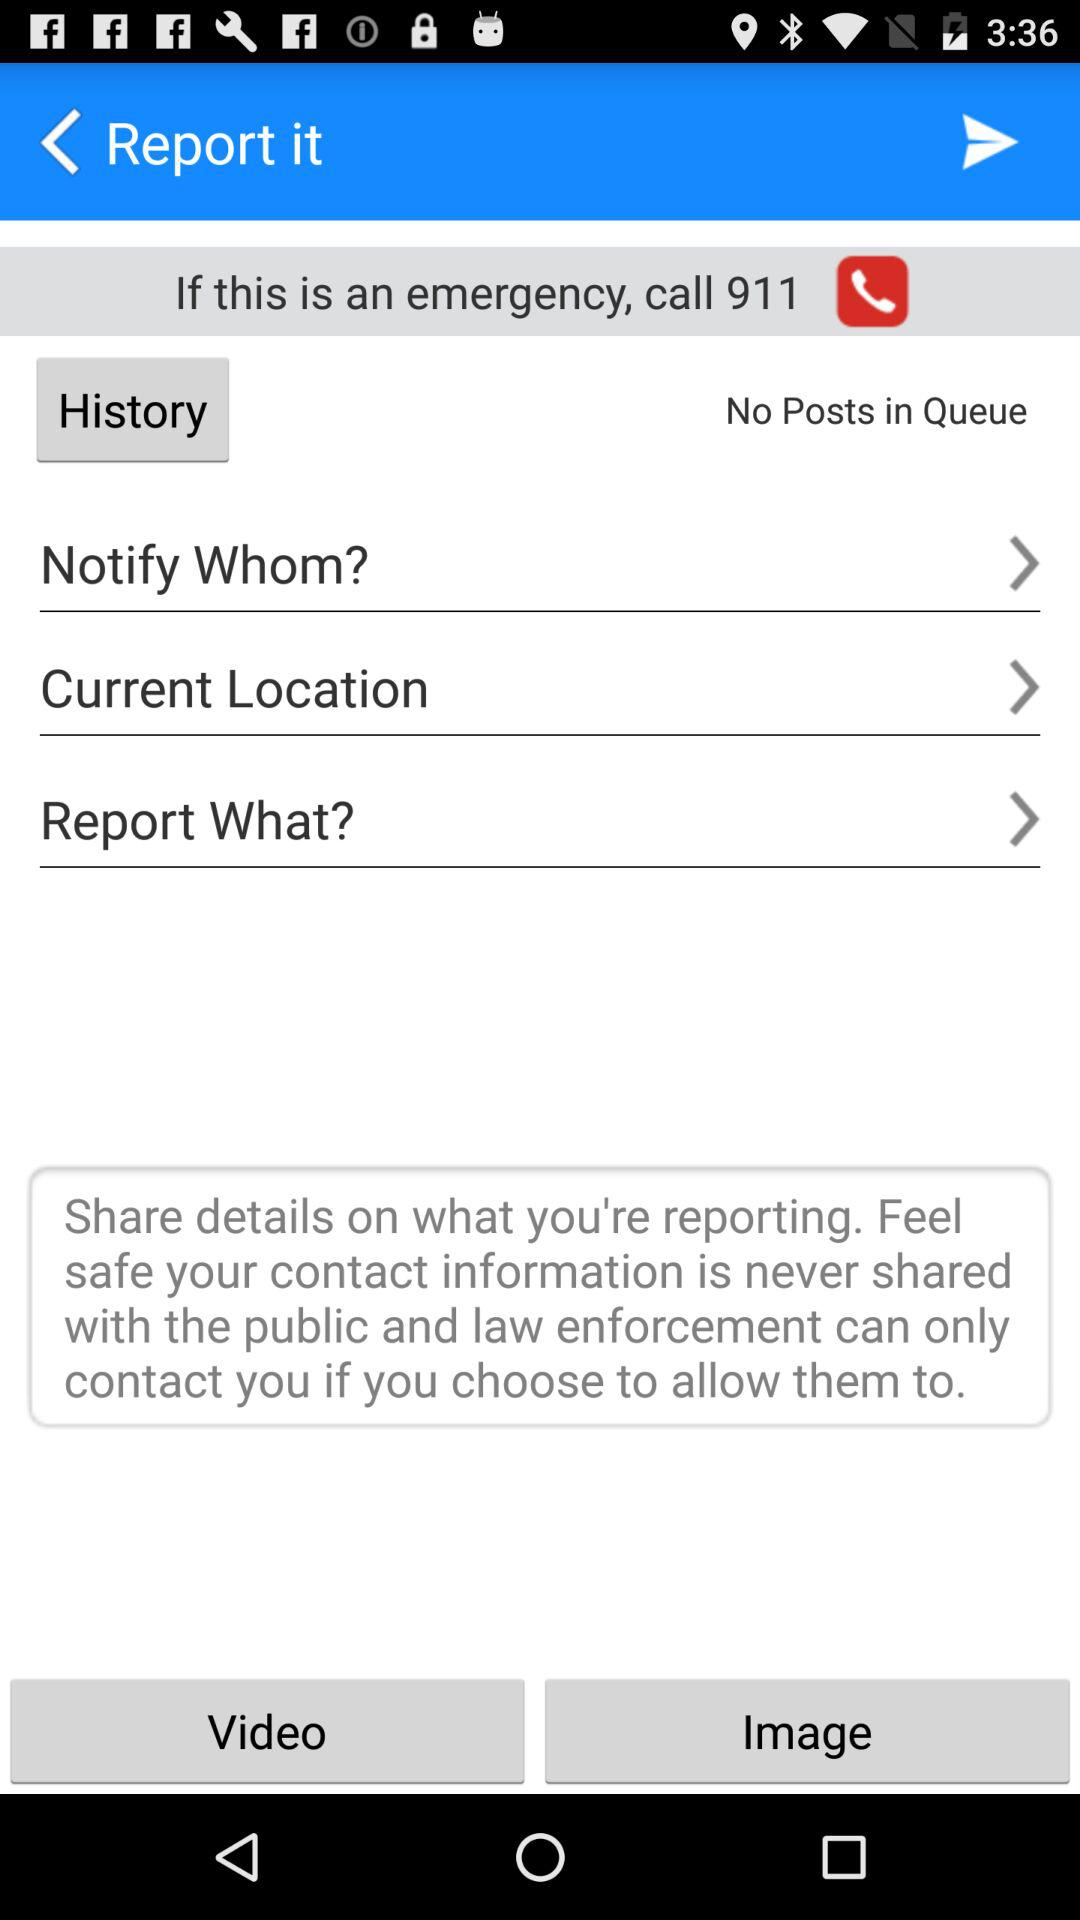What is the emergency number? The emergency number is 911. 